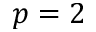<formula> <loc_0><loc_0><loc_500><loc_500>p = 2</formula> 